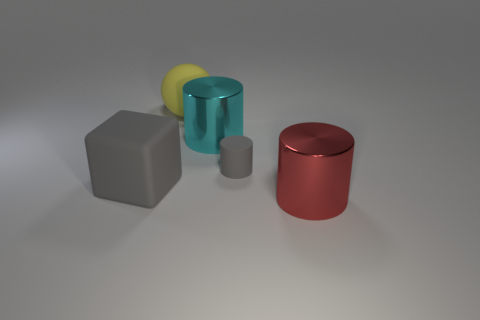What is the color of the other object that is the same material as the cyan thing?
Ensure brevity in your answer.  Red. Are there any large things that are to the left of the yellow rubber ball behind the large cyan thing?
Your response must be concise. Yes. What is the color of the matte block that is the same size as the cyan metallic object?
Offer a very short reply. Gray. What number of objects are either big rubber balls or tiny red matte cylinders?
Provide a succinct answer. 1. What size is the gray object on the right side of the shiny object that is on the left side of the big metallic thing that is in front of the large gray matte thing?
Your answer should be very brief. Small. What number of metal cylinders are the same color as the matte block?
Offer a terse response. 0. What number of big blocks are made of the same material as the cyan cylinder?
Ensure brevity in your answer.  0. How many objects are either large matte things or large cylinders that are on the right side of the tiny matte object?
Provide a succinct answer. 3. There is a large cylinder to the left of the big thing that is in front of the large object to the left of the sphere; what is its color?
Your answer should be very brief. Cyan. There is a thing that is on the left side of the large yellow rubber ball; what is its size?
Make the answer very short. Large. 